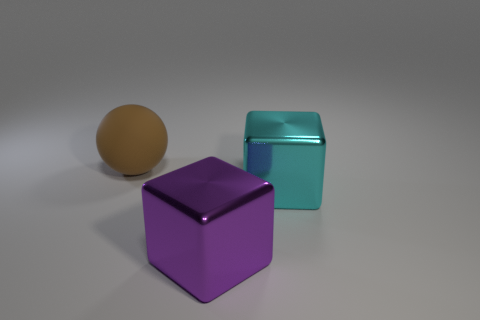Is there any other thing that has the same size as the brown ball?
Give a very brief answer. Yes. There is another big cube that is made of the same material as the cyan block; what color is it?
Offer a very short reply. Purple. Is the number of large brown things that are on the left side of the big matte thing less than the number of large blocks that are left of the purple shiny thing?
Your answer should be very brief. No. What number of balls are the same color as the large rubber thing?
Ensure brevity in your answer.  0. How many objects are left of the big purple object and to the right of the matte sphere?
Your answer should be compact. 0. There is a thing that is in front of the big shiny block to the right of the purple thing; what is it made of?
Ensure brevity in your answer.  Metal. Are there any big cyan things that have the same material as the big sphere?
Make the answer very short. No. What material is the other cyan object that is the same size as the rubber object?
Make the answer very short. Metal. There is a object behind the block that is on the right side of the big thing that is in front of the big cyan object; what is its size?
Provide a short and direct response. Large. Is there a large brown rubber sphere right of the big cube on the right side of the large purple shiny cube?
Provide a succinct answer. No. 